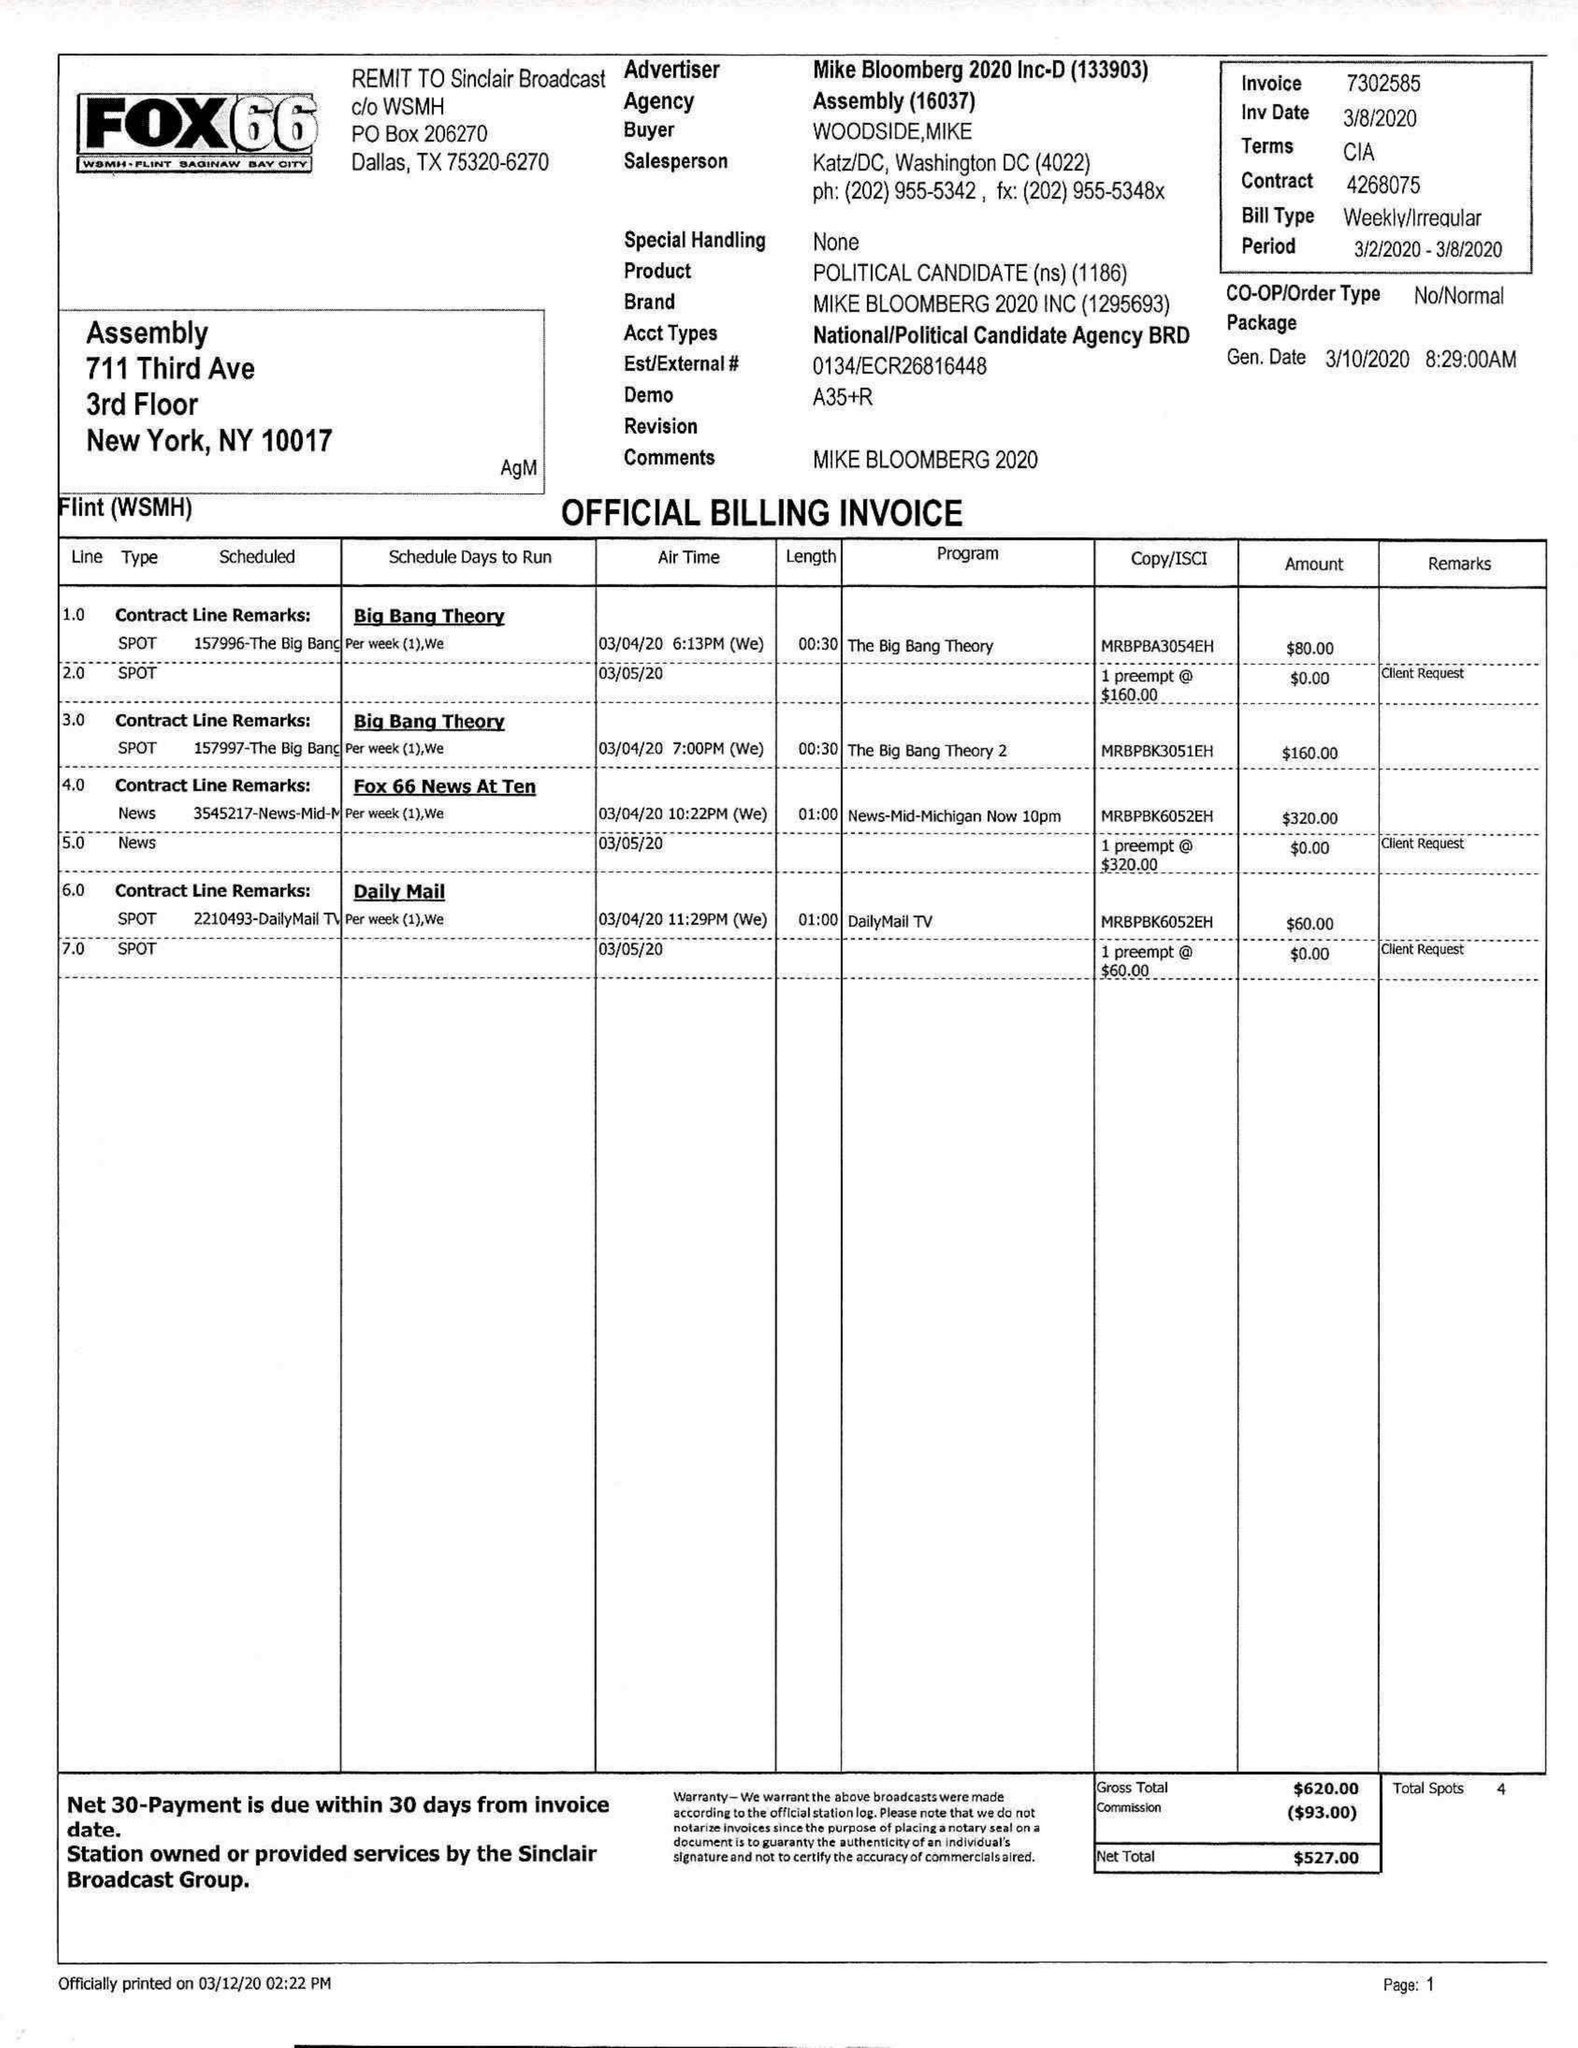What is the value for the contract_num?
Answer the question using a single word or phrase. 4268075 